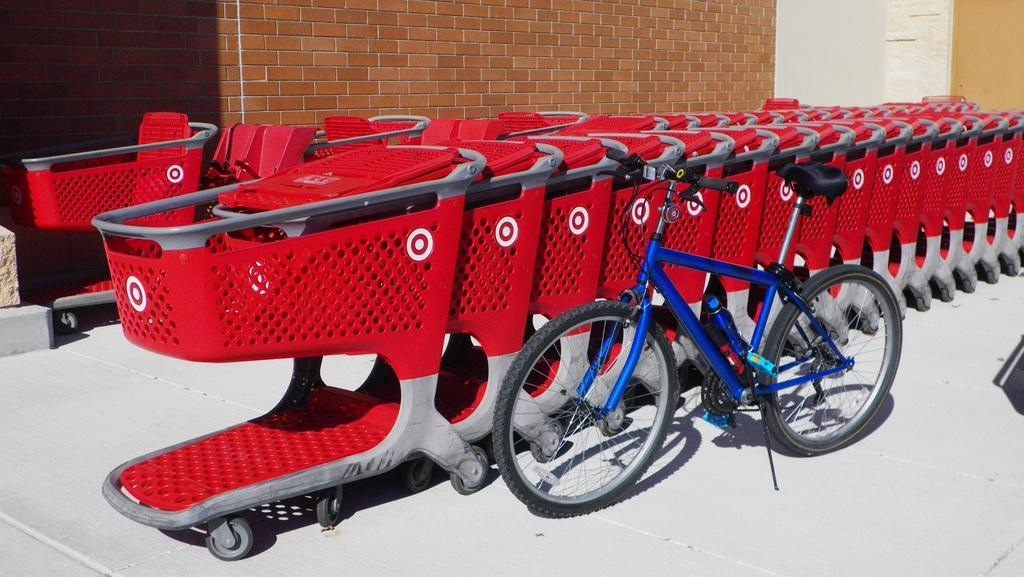What type of animals can be seen in the image? There is a group of cats in the image. What other object is present in the image? There is a bicycle in the image. Can you describe the object placed on the ground? A bottle is placed on the ground in the image. What can be seen in the background of the image? There is a wall visible in the background of the image. How many ladybugs are sitting on the cats in the image? There are no ladybugs present in the image; it features a group of cats, a bicycle, a bottle, and a wall in the background. 